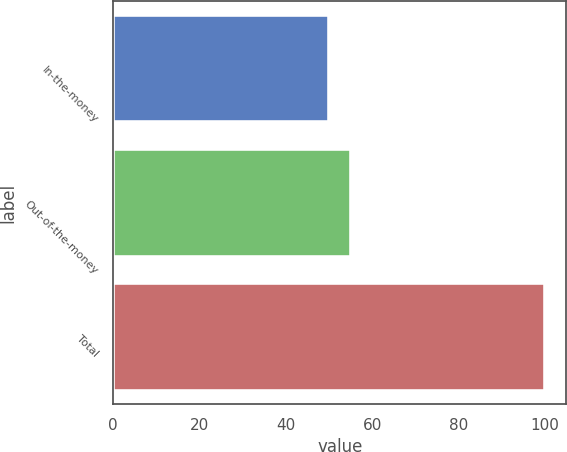Convert chart to OTSL. <chart><loc_0><loc_0><loc_500><loc_500><bar_chart><fcel>In-the-money<fcel>Out-of-the-money<fcel>Total<nl><fcel>50<fcel>55<fcel>100<nl></chart> 